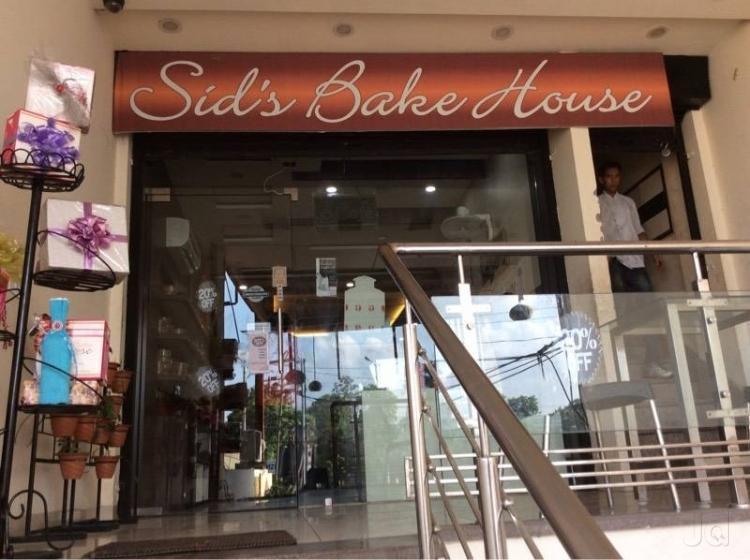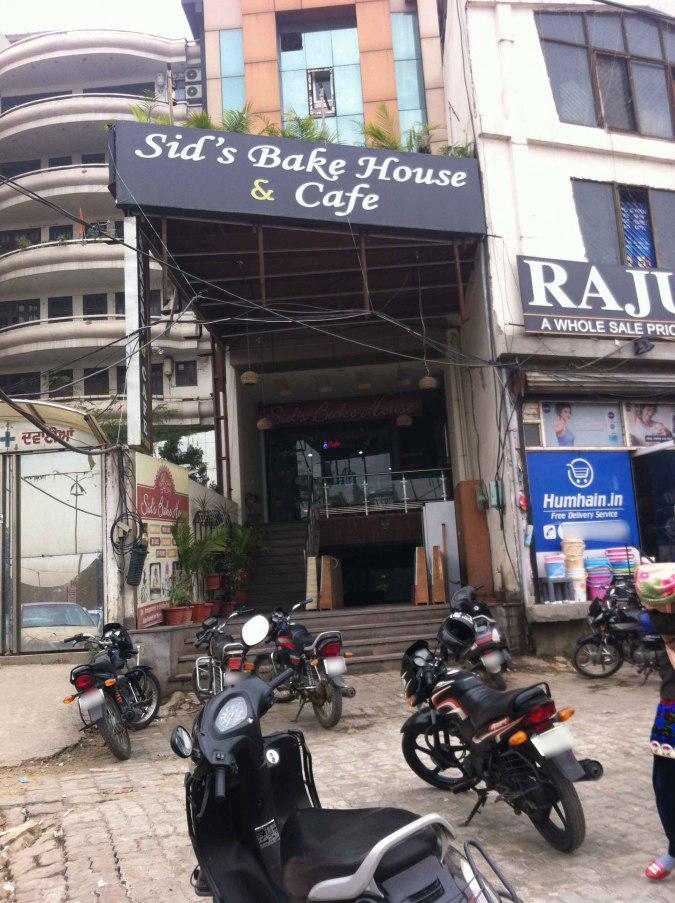The first image is the image on the left, the second image is the image on the right. Considering the images on both sides, is "Traingular pennants are on display in the image on the right." valid? Answer yes or no. No. 